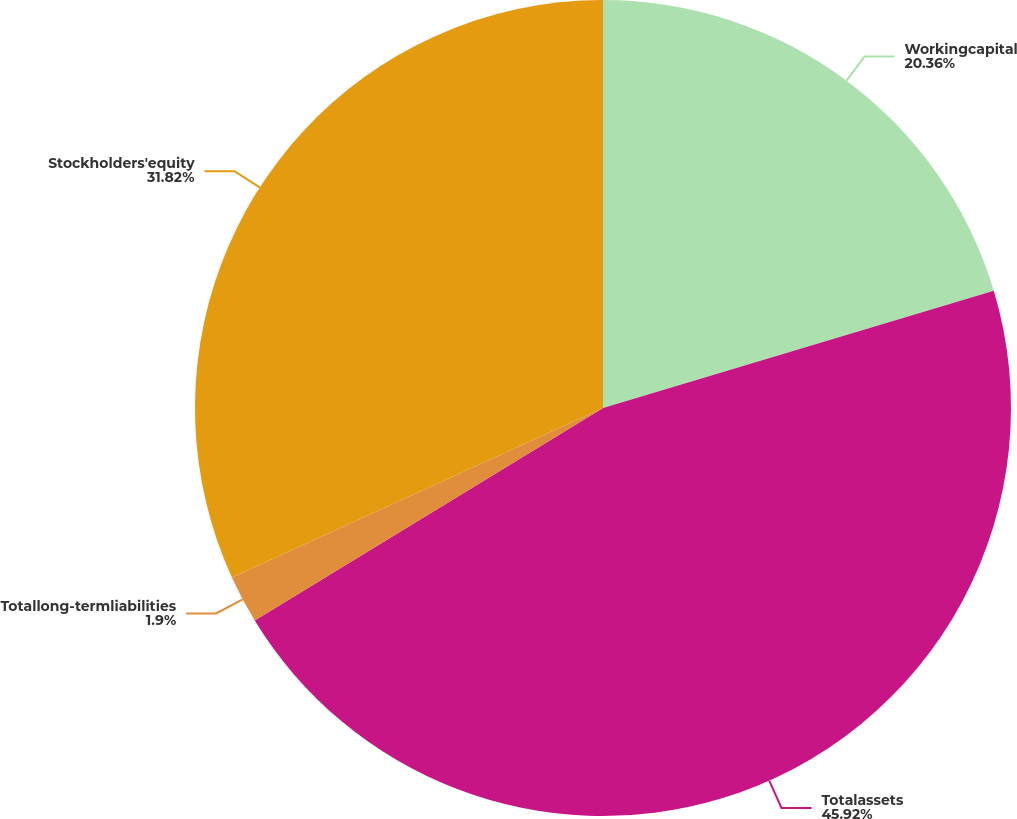<chart> <loc_0><loc_0><loc_500><loc_500><pie_chart><fcel>Workingcapital<fcel>Totalassets<fcel>Totallong-termliabilities<fcel>Stockholders'equity<nl><fcel>20.36%<fcel>45.92%<fcel>1.9%<fcel>31.82%<nl></chart> 